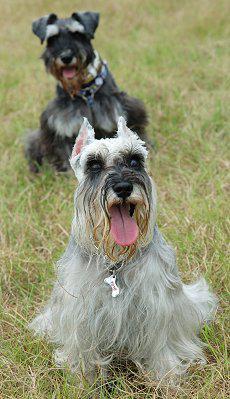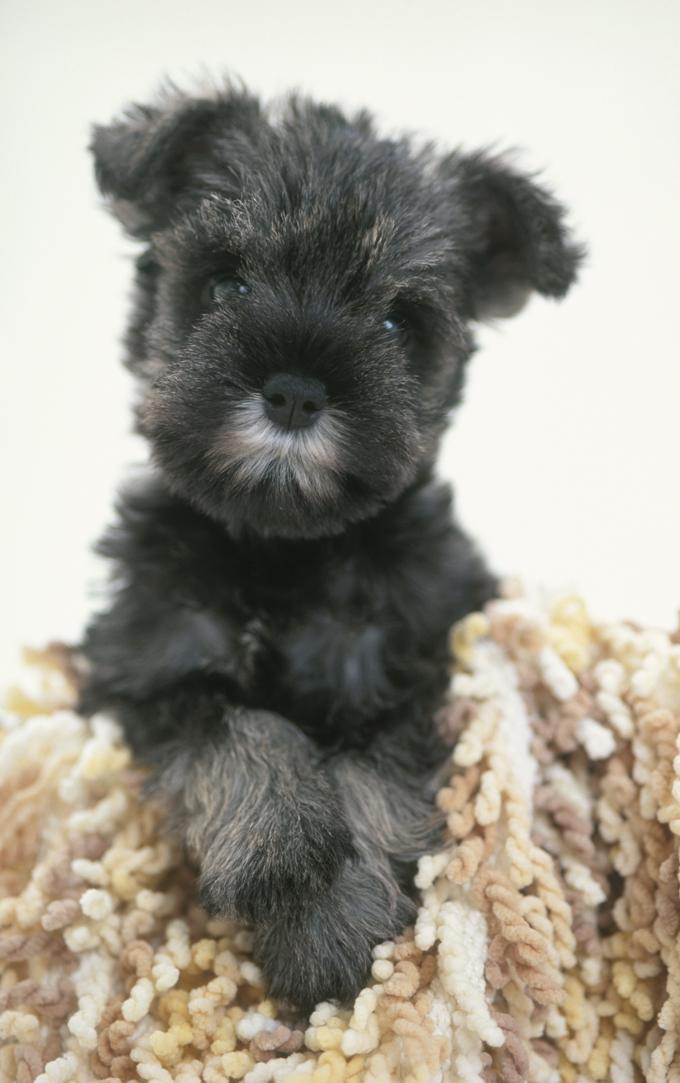The first image is the image on the left, the second image is the image on the right. For the images displayed, is the sentence "The dogs in the images are all looking straight ahead" factually correct? Answer yes or no. Yes. The first image is the image on the left, the second image is the image on the right. For the images shown, is this caption "At least one of the dogs is directly on the grass." true? Answer yes or no. Yes. 